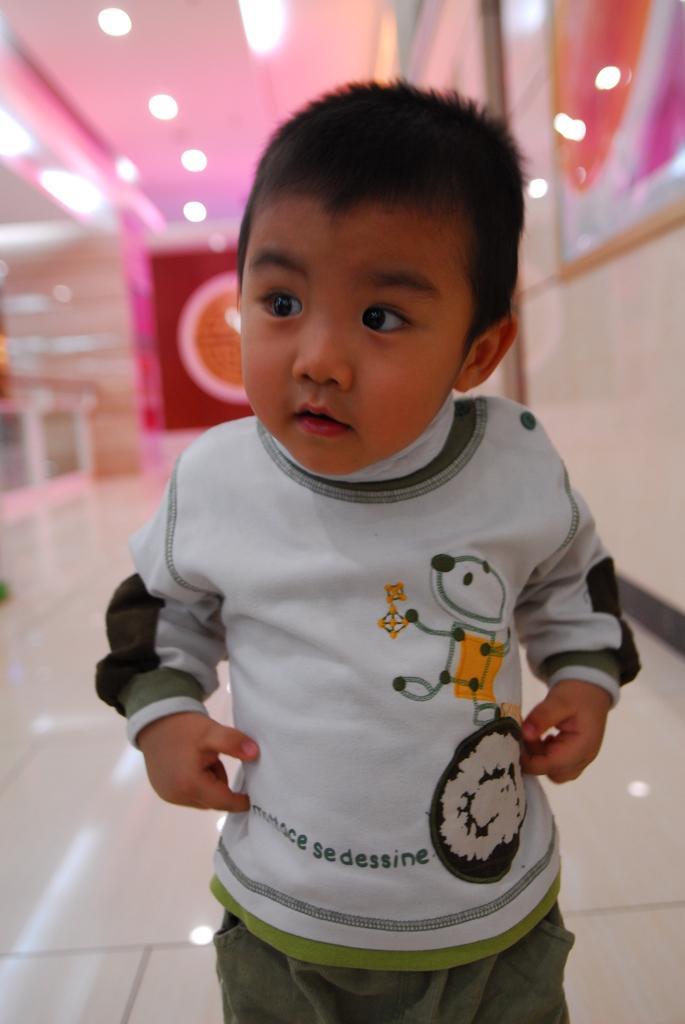Can you describe this image briefly? Here we can see a kid and this is floor. In the background we can see lights, ceiling, and wall. 